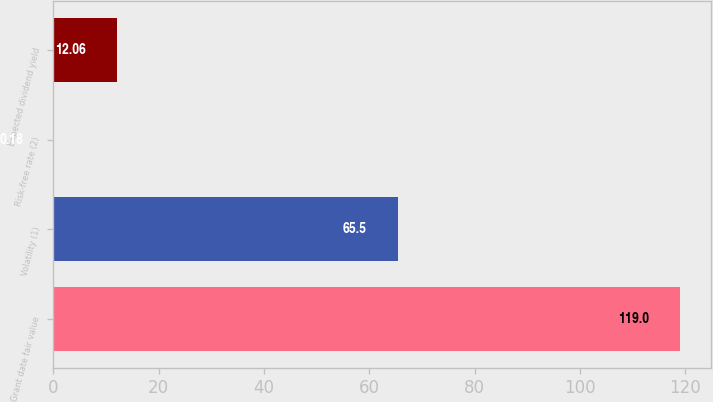Convert chart. <chart><loc_0><loc_0><loc_500><loc_500><bar_chart><fcel>Grant date fair value<fcel>Volatility (1)<fcel>Risk-free rate (2)<fcel>Expected dividend yield<nl><fcel>119<fcel>65.5<fcel>0.18<fcel>12.06<nl></chart> 